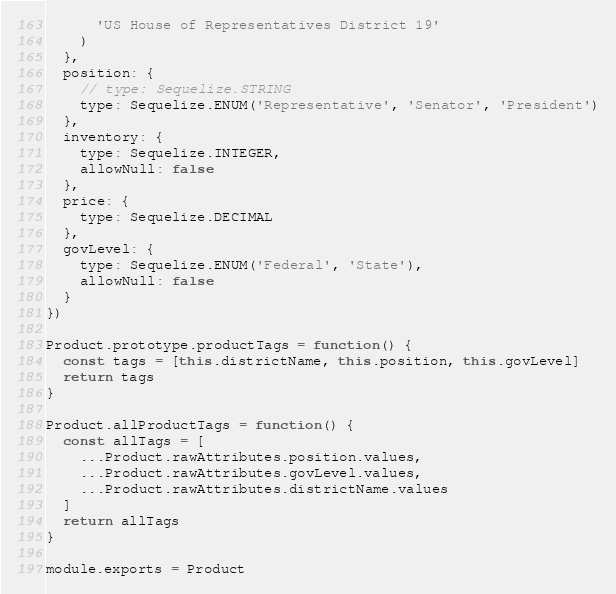<code> <loc_0><loc_0><loc_500><loc_500><_JavaScript_>      'US House of Representatives District 19'
    )
  },
  position: {
    // type: Sequelize.STRING
    type: Sequelize.ENUM('Representative', 'Senator', 'President')
  },
  inventory: {
    type: Sequelize.INTEGER,
    allowNull: false
  },
  price: {
    type: Sequelize.DECIMAL
  },
  govLevel: {
    type: Sequelize.ENUM('Federal', 'State'),
    allowNull: false
  }
})

Product.prototype.productTags = function() {
  const tags = [this.districtName, this.position, this.govLevel]
  return tags
}

Product.allProductTags = function() {
  const allTags = [
    ...Product.rawAttributes.position.values,
    ...Product.rawAttributes.govLevel.values,
    ...Product.rawAttributes.districtName.values
  ]
  return allTags
}

module.exports = Product
</code> 